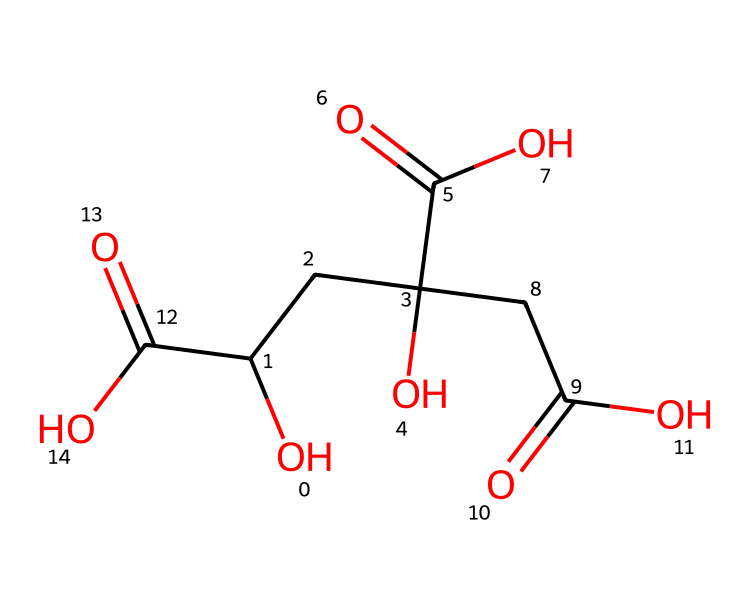What is the name of this chemical? The given SMILES indicates a compound with the structural features typical of citric acid, which is commonly found in citrus fruits.
Answer: citric acid How many carbon atoms are present in citric acid? By analyzing the SMILES representation, we can count each carbon (C) symbol. There are six carbon atoms total in the structure.
Answer: six What functional groups are present in citric acid? Citric acid contains several functional groups, such as hydroxyl (-OH) and carboxylic acid (-COOH). From the structure, you can identify these groups.
Answer: hydroxyl and carboxylic acid What is the pH nature of citric acid? Citric acid is a weak acid, as it partially dissociates in water, showing its acidic characteristics due to the presence of carboxylic acid groups.
Answer: weak acid How many carboxylic acid groups are in citric acid? By inspecting the SMILES and counting the occurrences of the carboxylic acid part (-COOH), we find there are three carboxylic acid groups present.
Answer: three What role does citric acid play in cleaning products? Citric acid acts as a natural cleaning agent due to its ability to chelate metal ions and its antibacterial properties, making it effective for cleaning.
Answer: natural cleaning agent Which molecular feature contributes to citric acid's acidity? The presence of multiple carboxylic acid functional groups (-COOH) in the structure contributes to citric acid's overall acidity by providing protons (H+) in solution.
Answer: carboxylic acid groups 